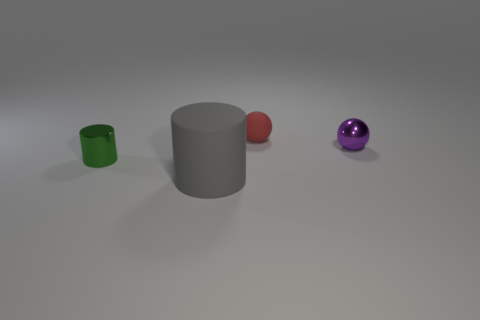Add 4 brown matte cylinders. How many objects exist? 8 Add 4 tiny purple metal objects. How many tiny purple metal objects exist? 5 Subtract 0 cyan cylinders. How many objects are left? 4 Subtract all big yellow matte cylinders. Subtract all tiny metal cylinders. How many objects are left? 3 Add 4 tiny matte objects. How many tiny matte objects are left? 5 